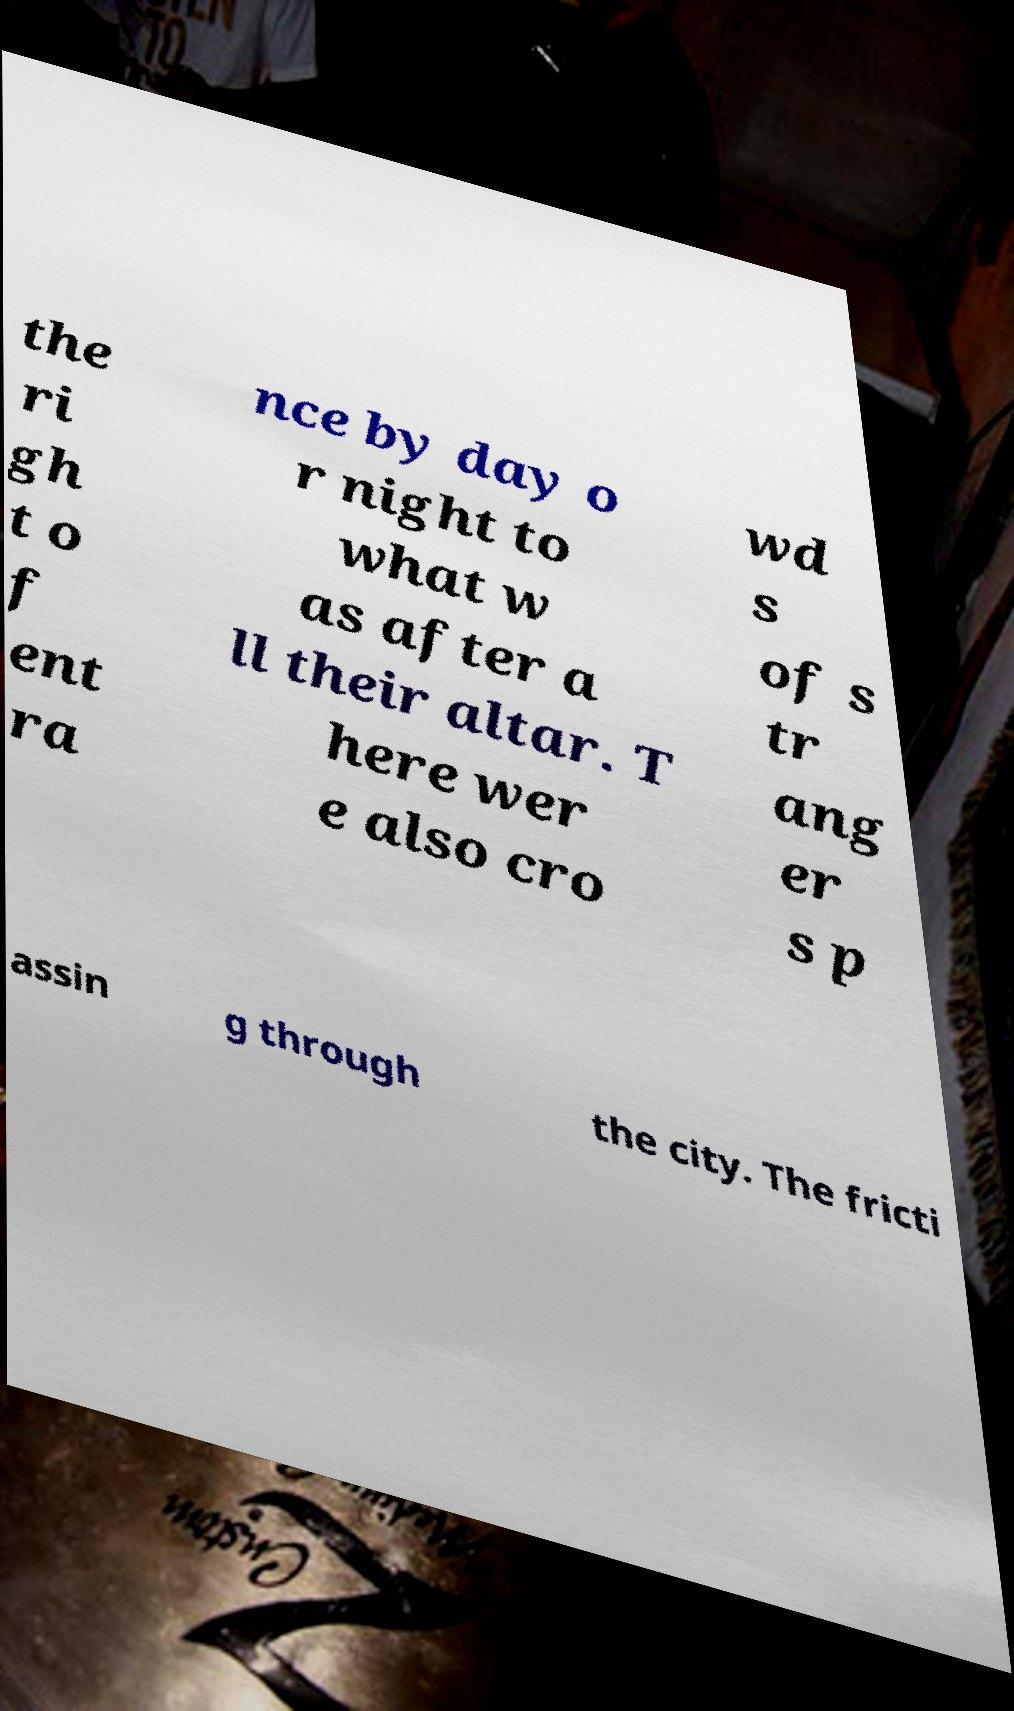Can you read and provide the text displayed in the image?This photo seems to have some interesting text. Can you extract and type it out for me? the ri gh t o f ent ra nce by day o r night to what w as after a ll their altar. T here wer e also cro wd s of s tr ang er s p assin g through the city. The fricti 